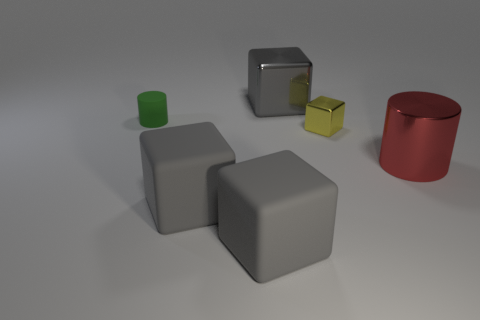How many green things are big metallic objects or tiny matte things?
Offer a terse response. 1. Do the red cylinder and the small cube have the same material?
Your response must be concise. Yes. Are there the same number of yellow blocks that are behind the yellow block and big objects right of the big metal cube?
Make the answer very short. No. There is another object that is the same shape as the small green matte thing; what is its material?
Give a very brief answer. Metal. There is a small shiny thing right of the cylinder that is left of the gray thing behind the tiny cube; what is its shape?
Offer a very short reply. Cube. Are there more large metal cylinders in front of the green rubber object than big cyan metallic cubes?
Provide a short and direct response. Yes. There is a tiny object that is to the right of the small cylinder; does it have the same shape as the large gray metal object?
Offer a terse response. Yes. There is a thing right of the small yellow shiny thing; what is it made of?
Give a very brief answer. Metal. What number of red metal objects are the same shape as the small rubber thing?
Provide a short and direct response. 1. There is a tiny thing that is right of the metallic block to the left of the yellow shiny block; what is its material?
Your response must be concise. Metal. 